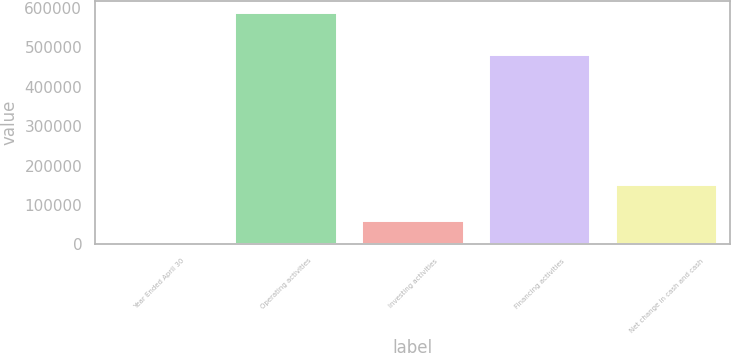Convert chart to OTSL. <chart><loc_0><loc_0><loc_500><loc_500><bar_chart><fcel>Year Ended April 30<fcel>Operating activities<fcel>Investing activities<fcel>Financing activities<fcel>Net change in cash and cash<nl><fcel>2010<fcel>587469<fcel>60555.9<fcel>481118<fcel>149382<nl></chart> 